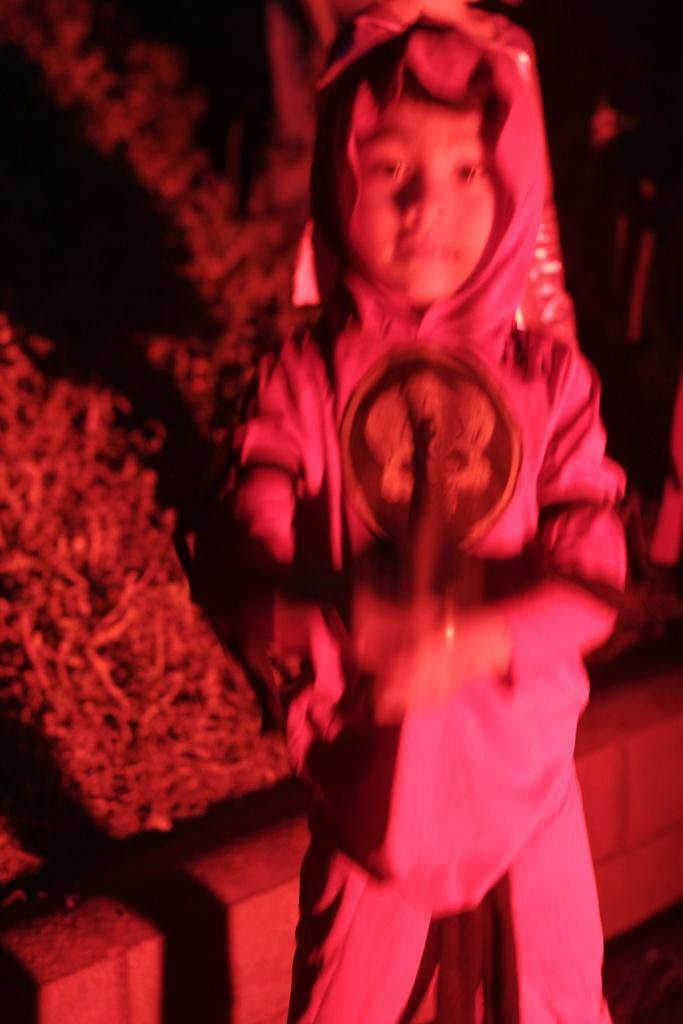What is the main subject of the image? There is a boy standing in the image. What can be seen in the background of the image? There is grass and a barrier visible in the background of the image. How many apples are on the square table in the image? There is no table, square or otherwise, nor any apples present in the image. 